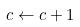<formula> <loc_0><loc_0><loc_500><loc_500>c \leftarrow c + 1</formula> 